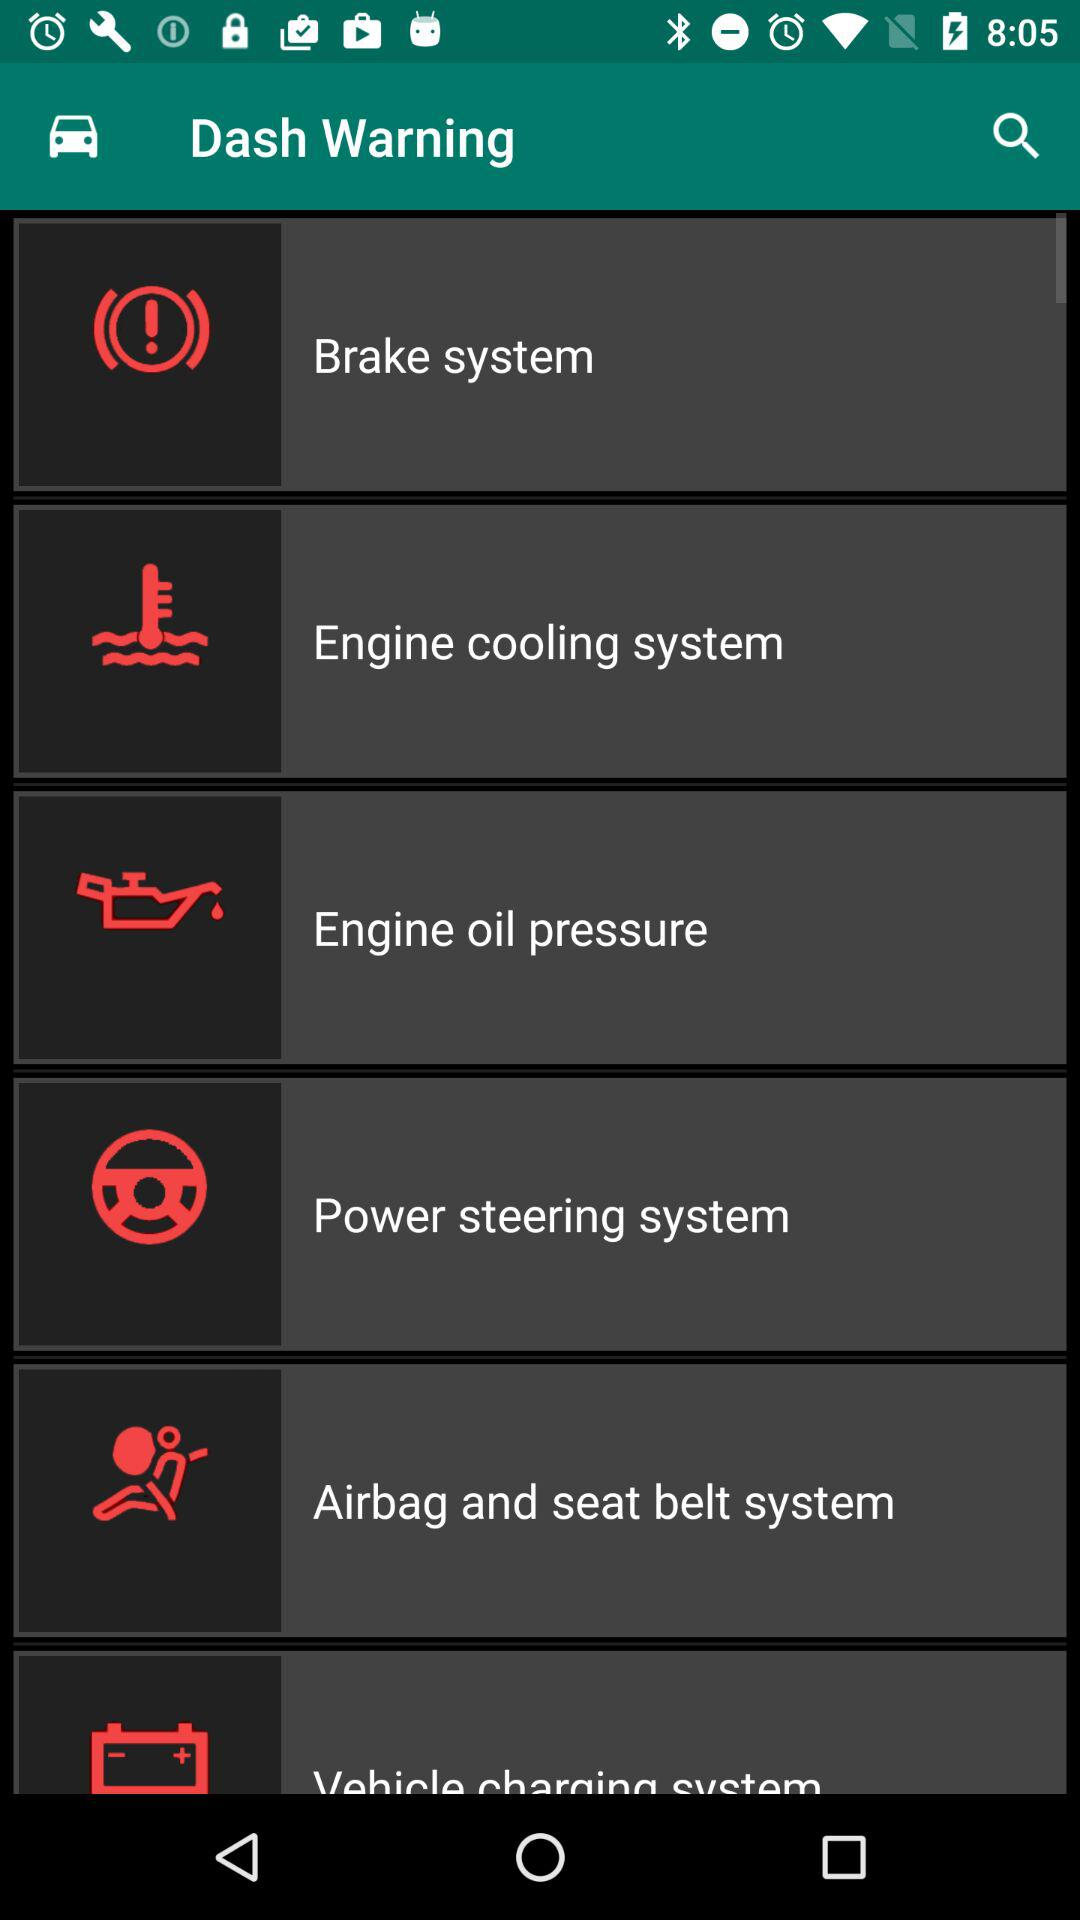What are the "Dash Warning" available? The available "Dash Warning" are: "Brake system", "Engine cooling system", "Engine oil pressure", "Power steering system", and "Airbag and seat belt system". 